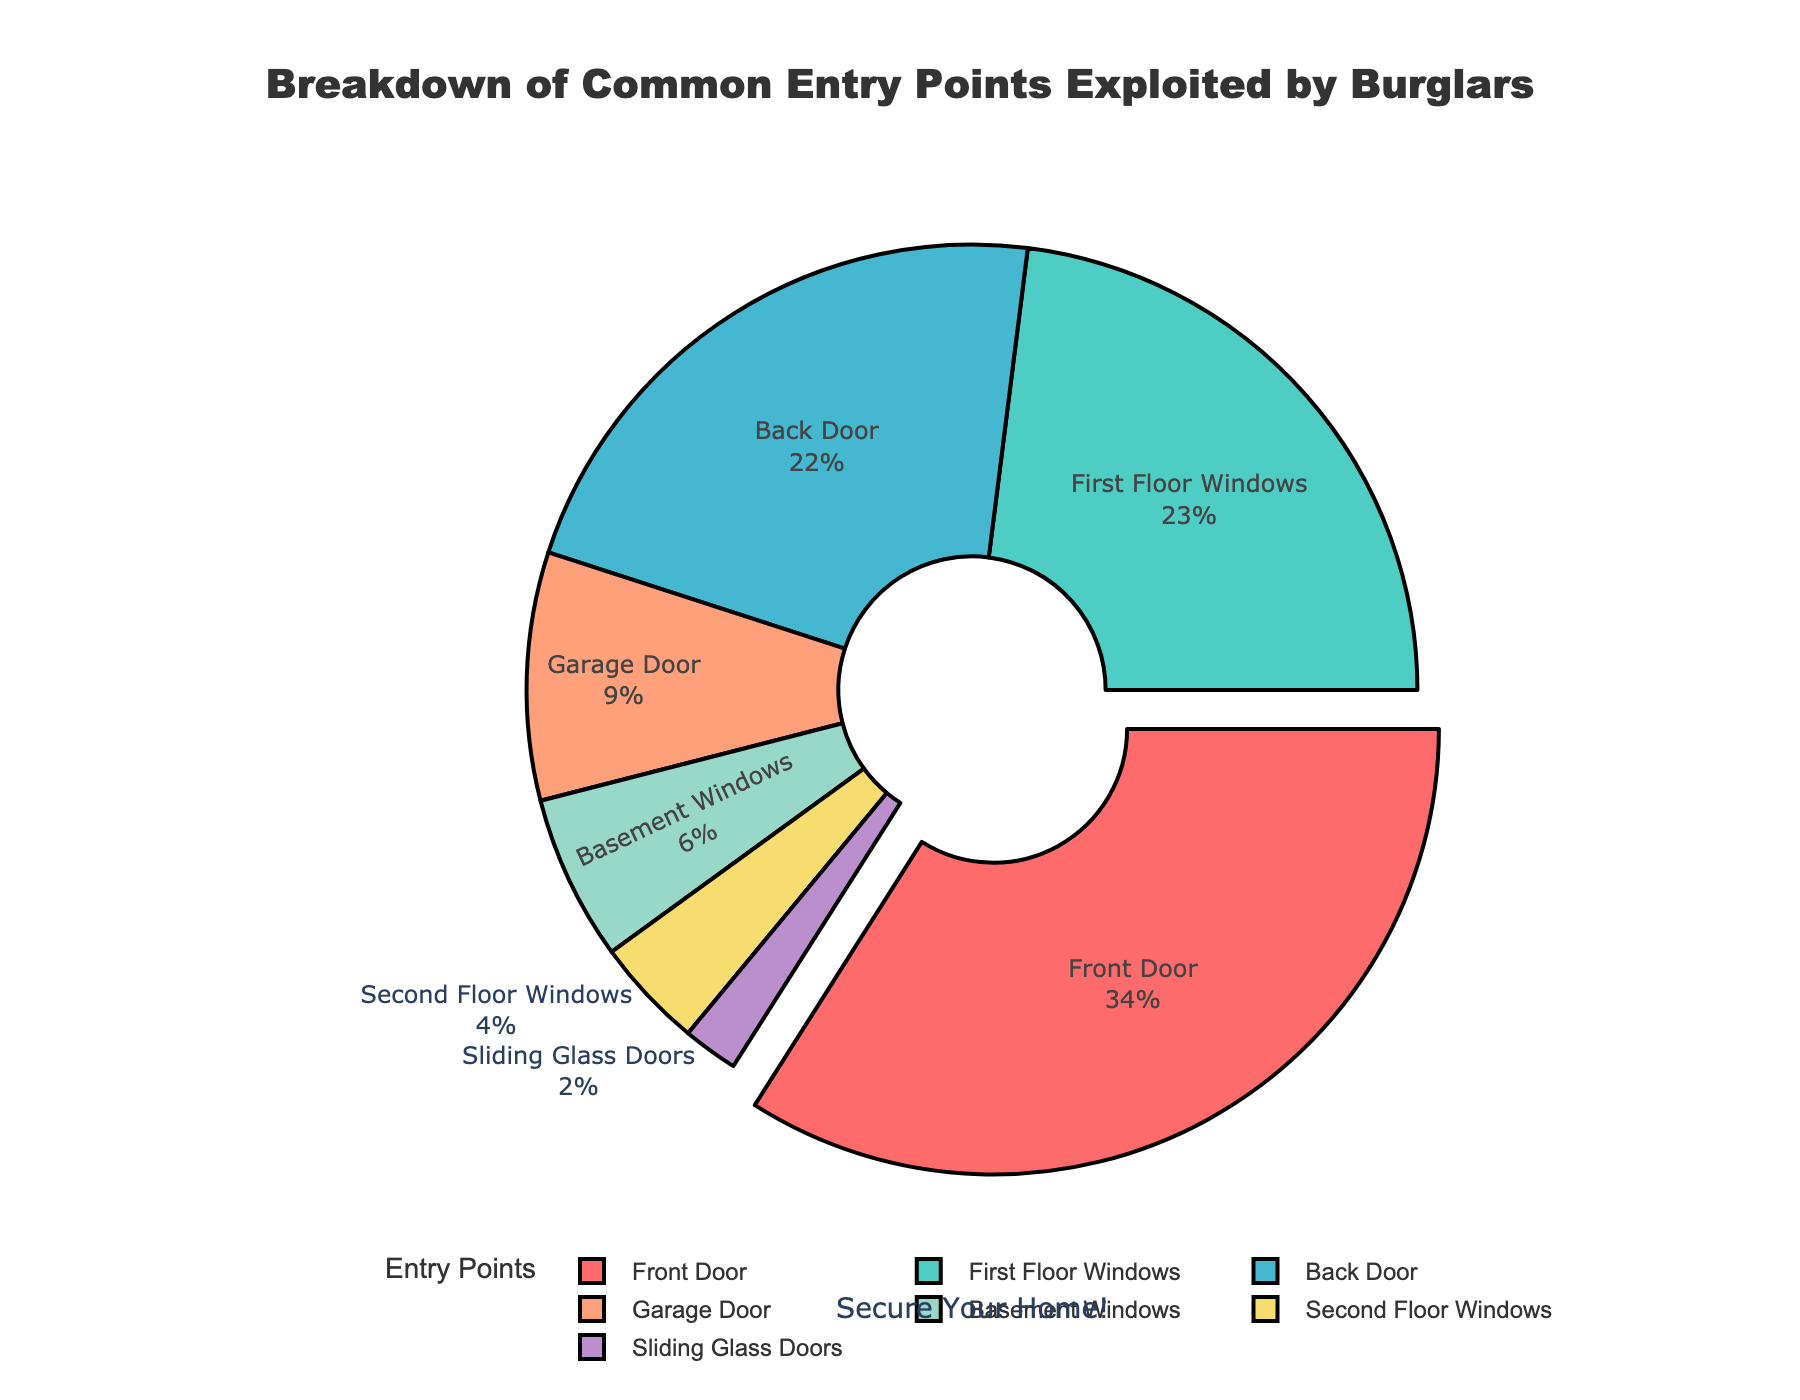Which entry point is the most commonly exploited by burglars? The front door is the largest section of the pie chart. It's also pulled out slightly from the rest, which further highlights its significance.
Answer: Front Door What percentage of burglaries occur through windows (First Floor, Basement, and Second Floor combined)? Sum the percentages of First Floor Windows, Basement Windows, and Second Floor Windows: 23% + 6% + 4% = 33%.
Answer: 33% How does the percentage of burglaries through the garage door compare to the back door? Garage Door is 9%, and Back Door is 22%. Since 9% is less than 22%, burglaries through the Garage Door are less common.
Answer: Less What are the least common entry points for burglaries based on the chart? The smallest sections of the pie chart are for Sliding Glass Doors with 2% and Second Floor Windows with 4%. These are the least common entry points.
Answer: Sliding Glass Doors, Second Floor Windows By how much does the percentage of burglaries through the front door exceed those through the basement windows? Subtract the percentage of Basement Windows (6%) from the percentage of Front Door (34%): 34% - 6% = 28%.
Answer: 28% What visual feature is used to emphasize the most common entry point? The front door section is pulled out slightly from the rest of the pie chart, making it visually prominent.
Answer: Pulled out How do the combined percentages of burglaries through the front door and back door compare to the total percentage? Sum the percentages of Front Door and Back Door: 34% + 22% = 56%. This combined percentage represents more than half of the pie chart.
Answer: 56%, more than half What percentage of burglaries do sliding glass doors account for, and how does this compare to garage doors? Sliding Glass Doors account for 2% and Garage Doors account for 9%. Sliding Glass Doors represent a smaller percentage than Garage Doors.
Answer: 2%, smaller than Garage Doors What logical reasoning can be made about the importance of securing first floor windows and front doors together? First Floor Windows represent 23% and Front Door represents 34%. Together, they account for (34% + 23% = 57%) of all entry points, indicating these areas are critical and should be secured.
Answer: Critical areas, 57% What visual aspect emphasizes the title and overall theme of the pie chart? The title is large, centered, and bold at the top of the pie chart, clearly indicating the topic. Additionally, an annotation "Secure Your Home!" is placed beneath the chart.
Answer: Large centered title, annotation 